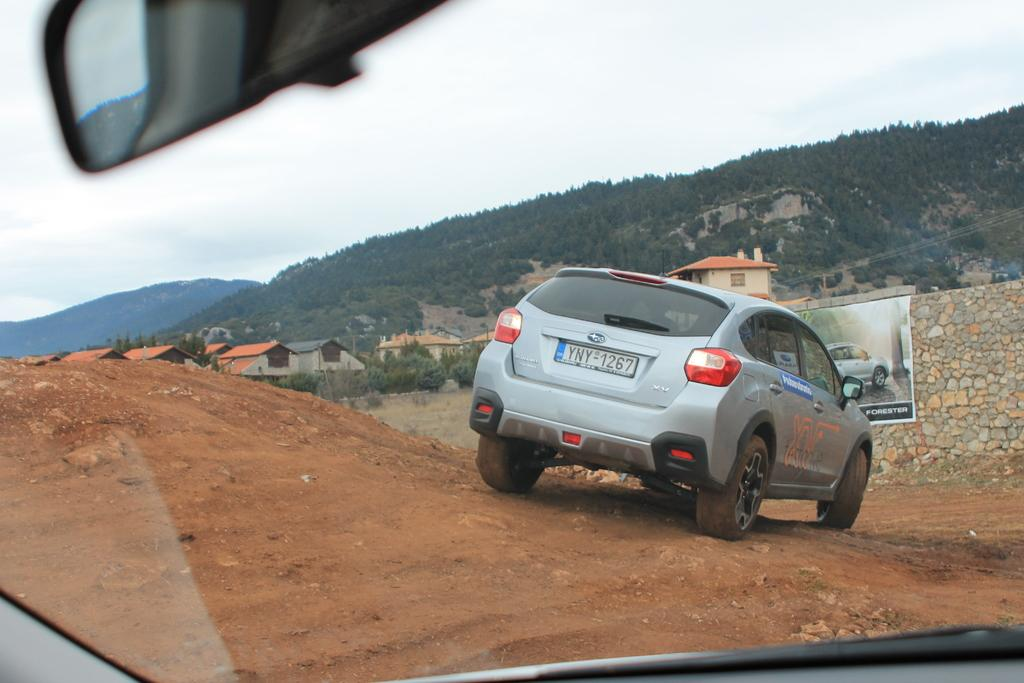What is the main subject in the image? There is a vehicle in the image. What can be seen in the background of the image? There are trees and buildings in the background of the image. Can you describe the hoarding in the image? The hoarding is on a rock wall in the image. How would you describe the weather in the image? The sky is cloudy in the image. Is there a doctor attending to a snake in the image? No, there is no doctor or snake present in the image. 